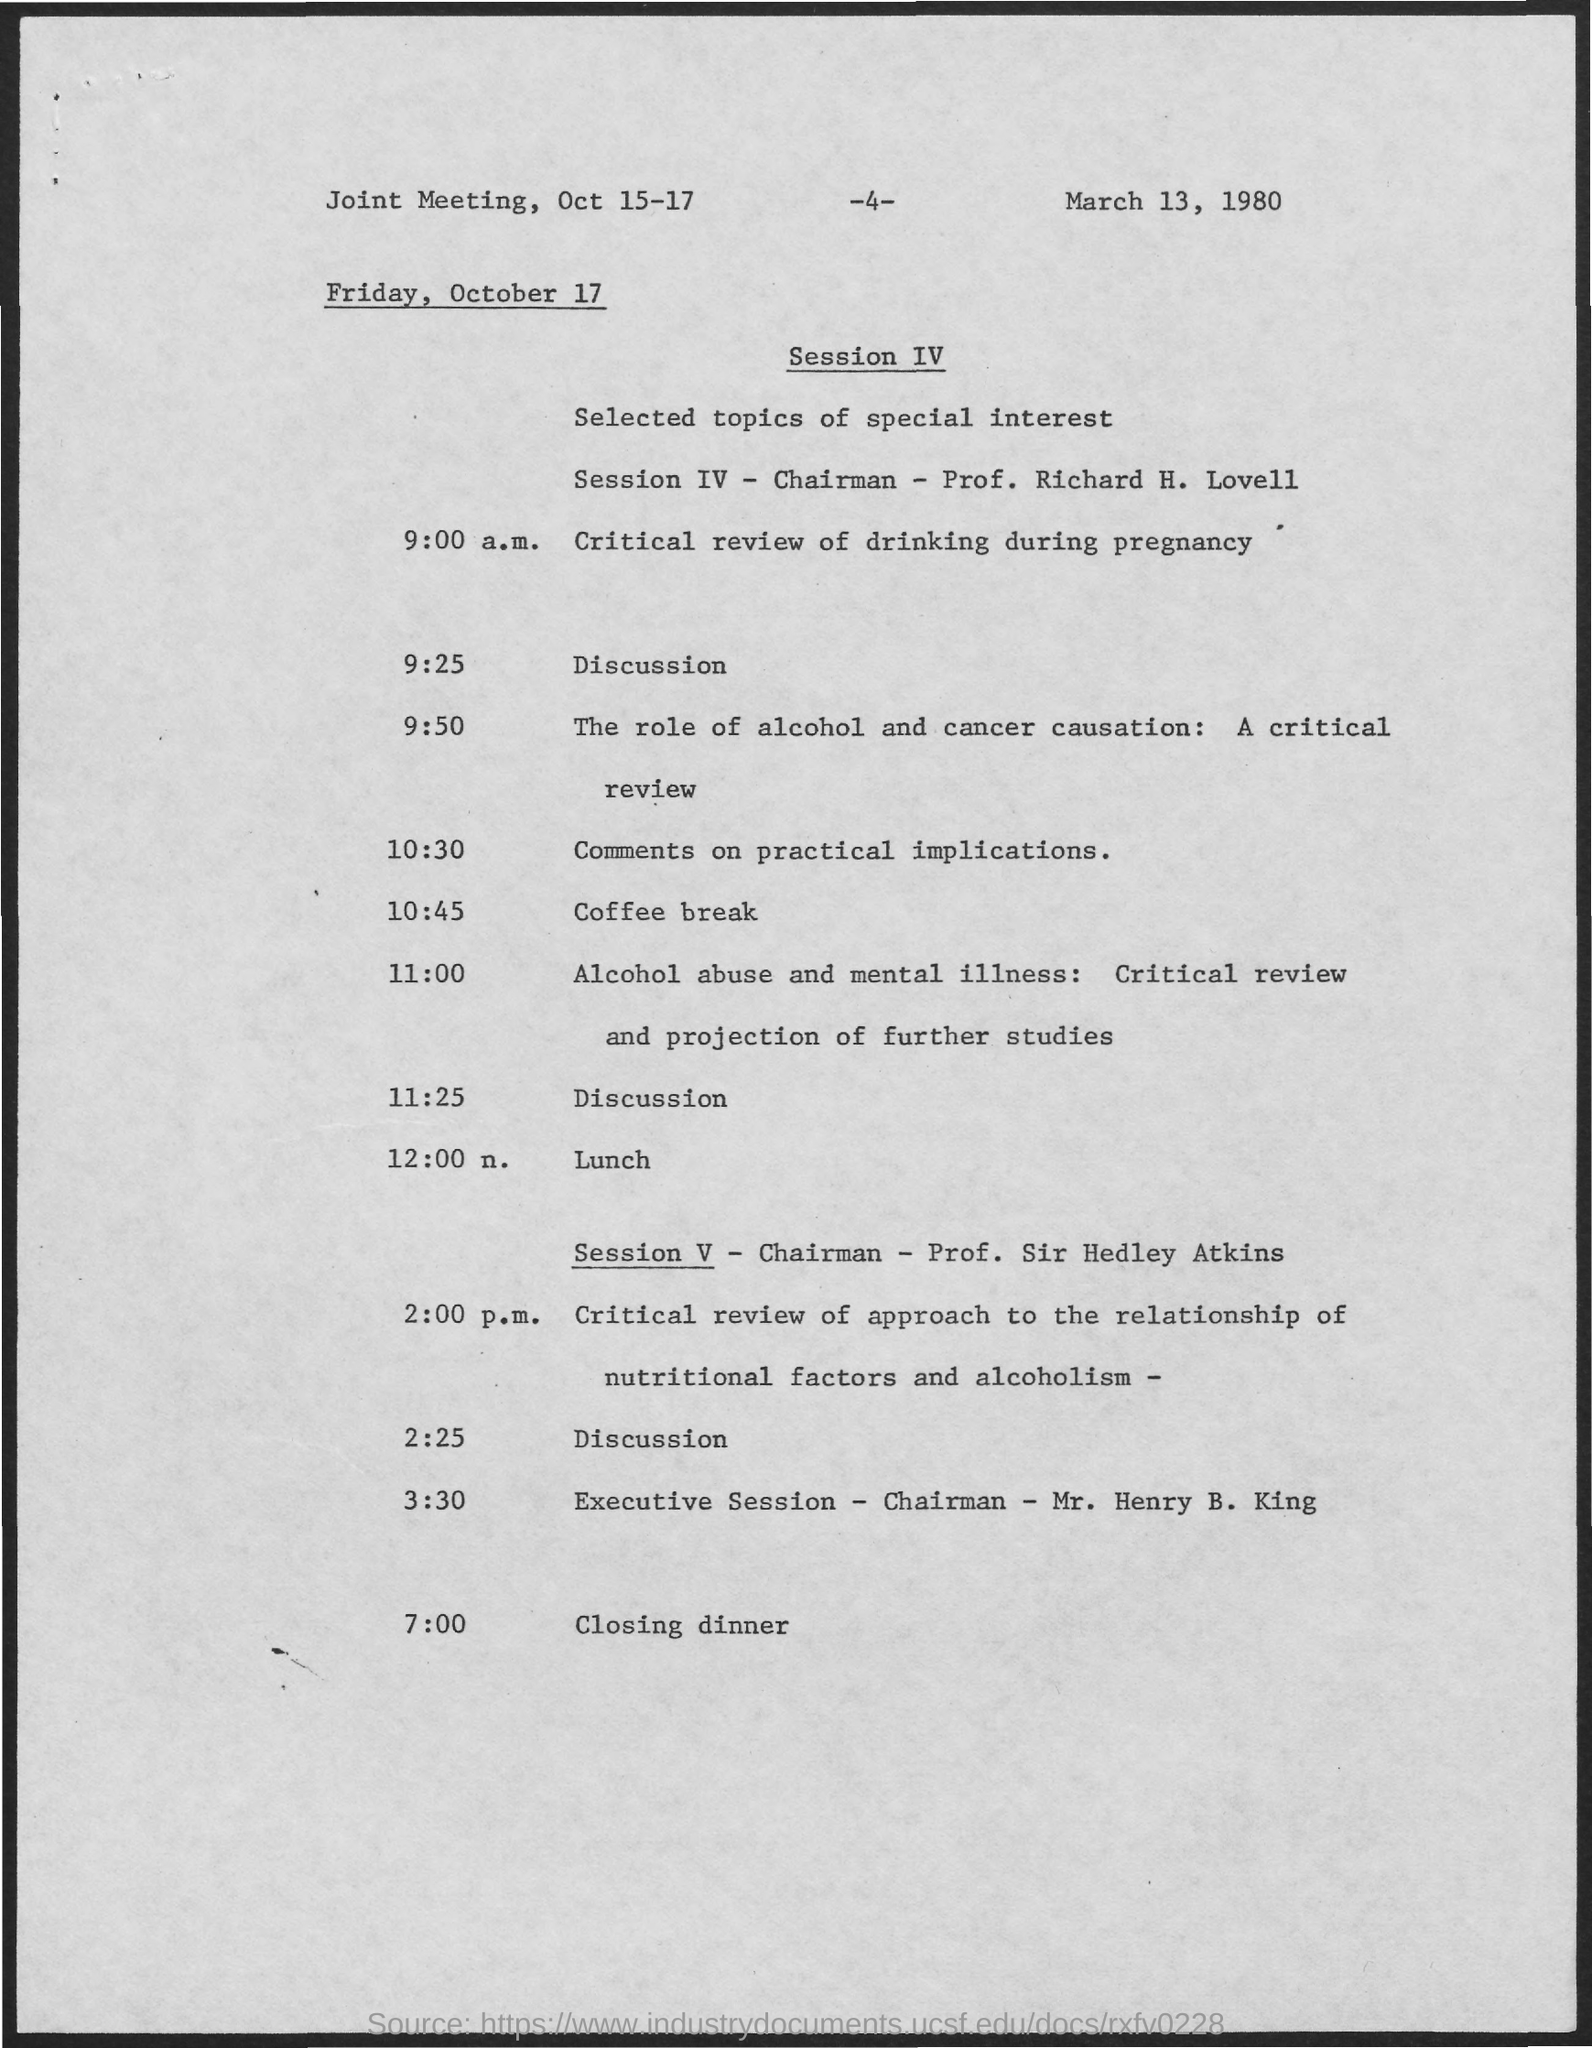Outline some significant characteristics in this image. Prof. Sir Hedley Atkins is the chairman for Session V. What is the scheduled time for lunch?" "12:00 noon. At 10:45, the scheduled time for the coffee break is. The page number at the top of the page is 4. The closing dinner is scheduled to begin at 7:00 PM. 